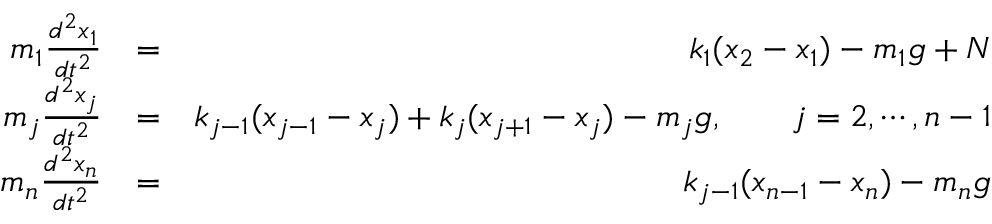<formula> <loc_0><loc_0><loc_500><loc_500>\begin{array} { r l r } { m _ { 1 } \frac { d ^ { 2 } x _ { 1 } } { d t ^ { 2 } } } & { = } & { k _ { 1 } ( x _ { 2 } - x _ { 1 } ) - m _ { 1 } g + N } \\ { m _ { j } \frac { d ^ { 2 } x _ { j } } { d t ^ { 2 } } } & { = } & { k _ { j - 1 } ( x _ { j - 1 } - x _ { j } ) + k _ { j } ( x _ { j + 1 } - x _ { j } ) - m _ { j } g , \quad j = 2 , \cdots , n - 1 } \\ { m _ { n } \frac { d ^ { 2 } x _ { n } } { d t ^ { 2 } } } & { = } & { k _ { j - 1 } ( x _ { n - 1 } - x _ { n } ) - m _ { n } g } \end{array}</formula> 